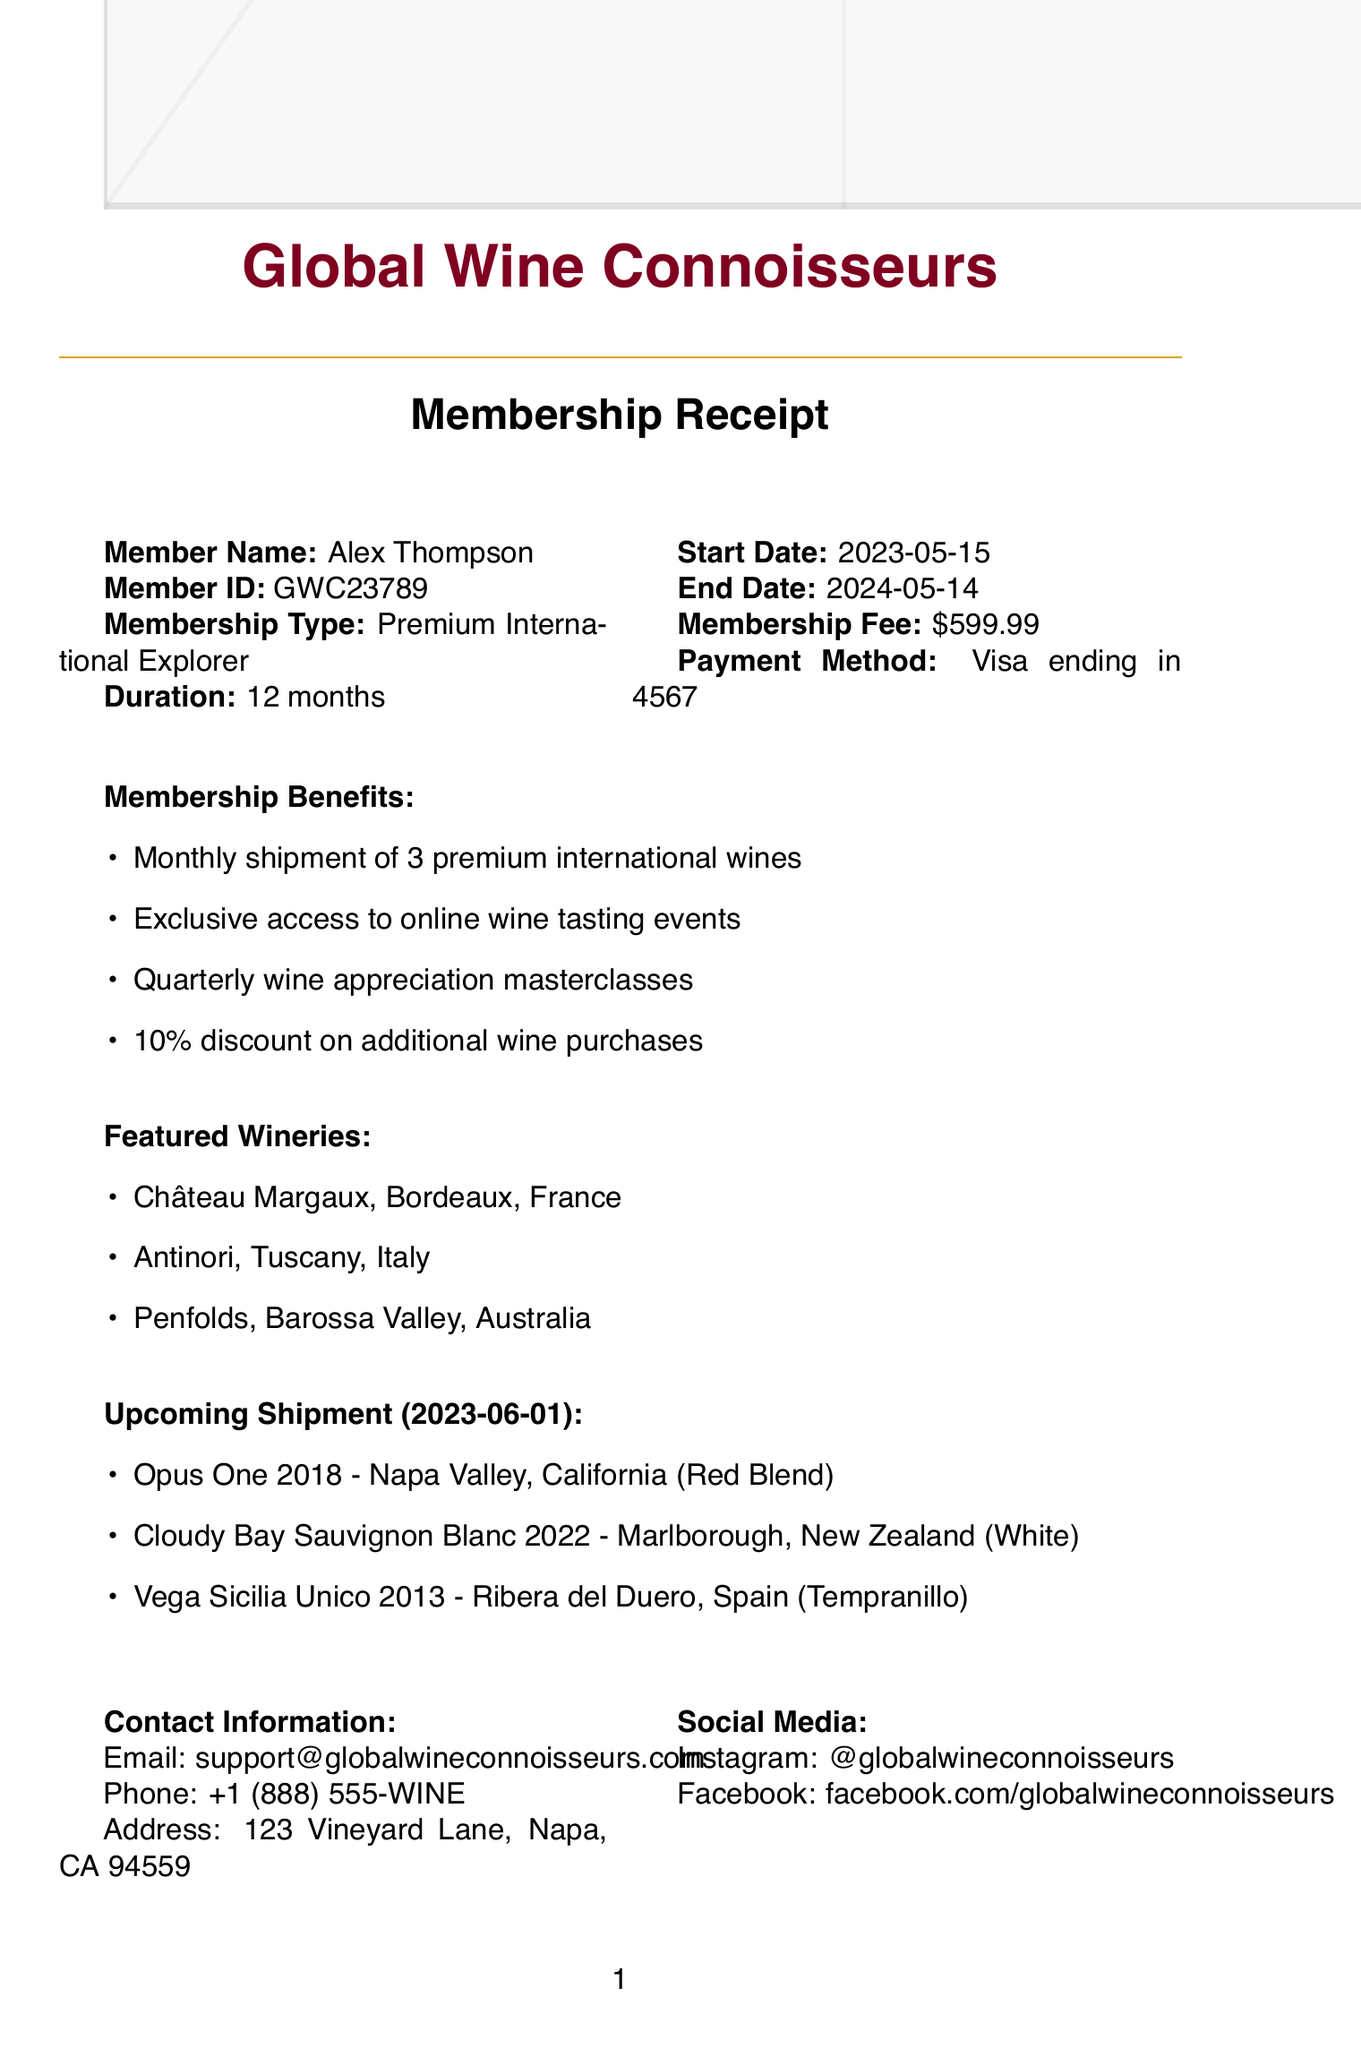What is the name of the wine club? The wine club is referred to as Global Wine Connoisseurs in the document.
Answer: Global Wine Connoisseurs What is the membership fee? The membership fee is explicitly stated in the document as $599.99.
Answer: $599.99 What is the duration of the membership? The duration of the membership is provided in the document as 12 months.
Answer: 12 months When does the membership start? The start date of the membership is noted as 2023-05-15 in the document.
Answer: 2023-05-15 What wines are included in the upcoming shipment? The document lists the wines in the upcoming shipment as Opus One 2018, Cloudy Bay Sauvignon Blanc 2022, and Vega Sicilia Unico 2013.
Answer: Opus One 2018, Cloudy Bay Sauvignon Blanc 2022, Vega Sicilia Unico 2013 How many wine tasting events are members given access to? The document states that members have exclusive access to online wine tasting events, implying at least one.
Answer: Online wine tasting events What is required for cancellation without penalty? The document mentions that a 30-day notice is required for cancellation without penalty.
Answer: 30-day notice What types of additional services are offered? The document lists services such as personal wine concierge, cellar management advice, and wine and food pairing consultations.
Answer: Personal wine concierge, cellar management advice, wine and food pairing consultations Can a gift membership be purchased? The document indicates that gift memberships are available.
Answer: Yes 